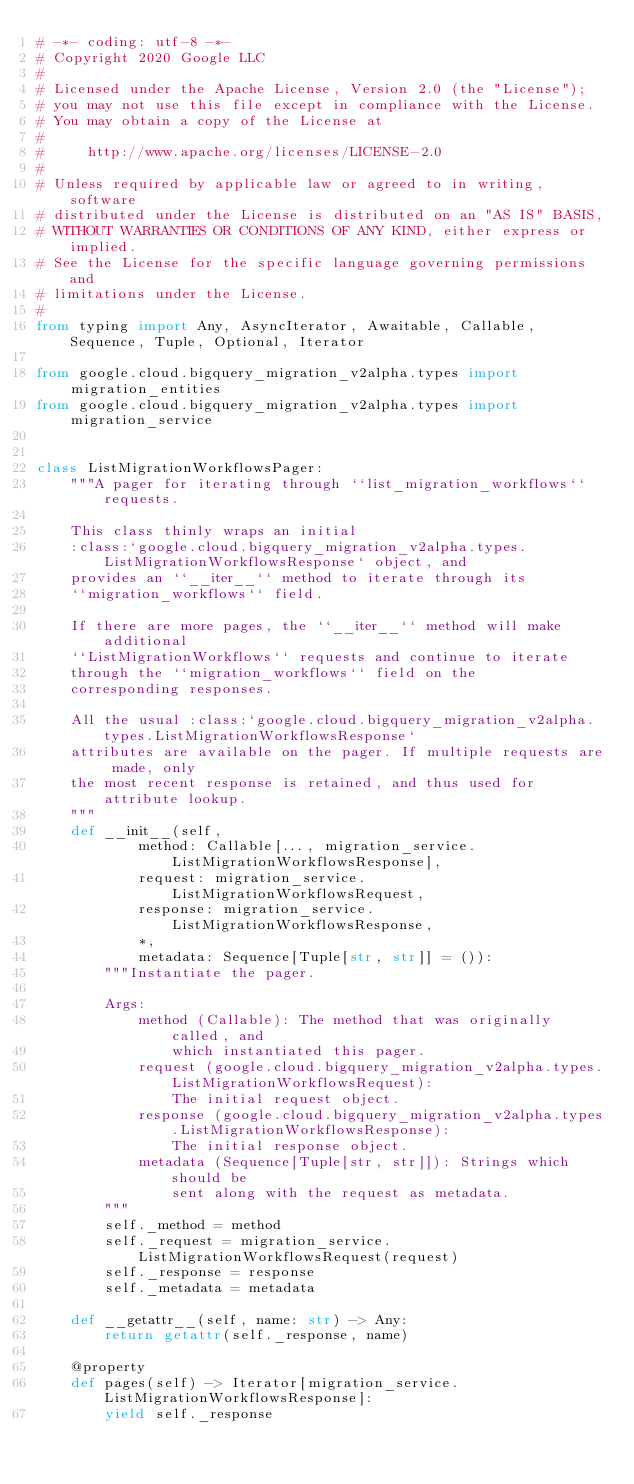Convert code to text. <code><loc_0><loc_0><loc_500><loc_500><_Python_># -*- coding: utf-8 -*-
# Copyright 2020 Google LLC
#
# Licensed under the Apache License, Version 2.0 (the "License");
# you may not use this file except in compliance with the License.
# You may obtain a copy of the License at
#
#     http://www.apache.org/licenses/LICENSE-2.0
#
# Unless required by applicable law or agreed to in writing, software
# distributed under the License is distributed on an "AS IS" BASIS,
# WITHOUT WARRANTIES OR CONDITIONS OF ANY KIND, either express or implied.
# See the License for the specific language governing permissions and
# limitations under the License.
#
from typing import Any, AsyncIterator, Awaitable, Callable, Sequence, Tuple, Optional, Iterator

from google.cloud.bigquery_migration_v2alpha.types import migration_entities
from google.cloud.bigquery_migration_v2alpha.types import migration_service


class ListMigrationWorkflowsPager:
    """A pager for iterating through ``list_migration_workflows`` requests.

    This class thinly wraps an initial
    :class:`google.cloud.bigquery_migration_v2alpha.types.ListMigrationWorkflowsResponse` object, and
    provides an ``__iter__`` method to iterate through its
    ``migration_workflows`` field.

    If there are more pages, the ``__iter__`` method will make additional
    ``ListMigrationWorkflows`` requests and continue to iterate
    through the ``migration_workflows`` field on the
    corresponding responses.

    All the usual :class:`google.cloud.bigquery_migration_v2alpha.types.ListMigrationWorkflowsResponse`
    attributes are available on the pager. If multiple requests are made, only
    the most recent response is retained, and thus used for attribute lookup.
    """
    def __init__(self,
            method: Callable[..., migration_service.ListMigrationWorkflowsResponse],
            request: migration_service.ListMigrationWorkflowsRequest,
            response: migration_service.ListMigrationWorkflowsResponse,
            *,
            metadata: Sequence[Tuple[str, str]] = ()):
        """Instantiate the pager.

        Args:
            method (Callable): The method that was originally called, and
                which instantiated this pager.
            request (google.cloud.bigquery_migration_v2alpha.types.ListMigrationWorkflowsRequest):
                The initial request object.
            response (google.cloud.bigquery_migration_v2alpha.types.ListMigrationWorkflowsResponse):
                The initial response object.
            metadata (Sequence[Tuple[str, str]]): Strings which should be
                sent along with the request as metadata.
        """
        self._method = method
        self._request = migration_service.ListMigrationWorkflowsRequest(request)
        self._response = response
        self._metadata = metadata

    def __getattr__(self, name: str) -> Any:
        return getattr(self._response, name)

    @property
    def pages(self) -> Iterator[migration_service.ListMigrationWorkflowsResponse]:
        yield self._response</code> 